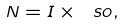<formula> <loc_0><loc_0><loc_500><loc_500>N = I \times \ s o ,</formula> 